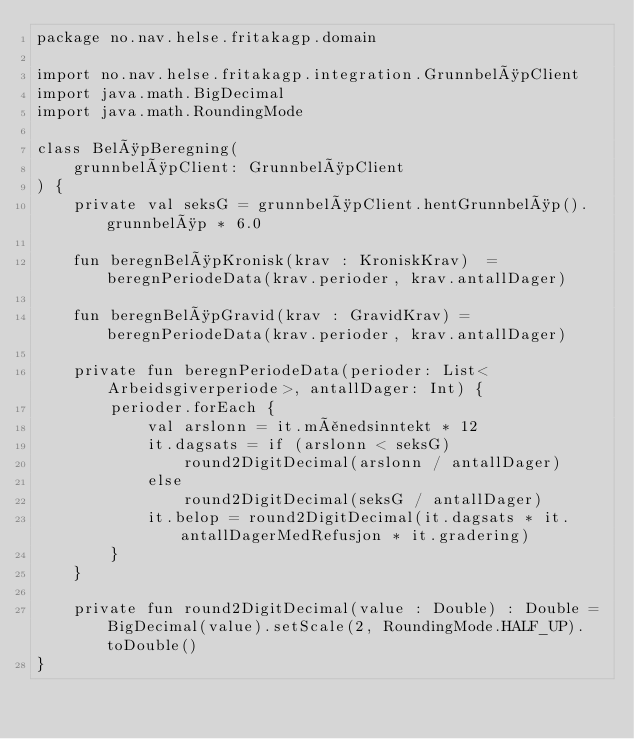Convert code to text. <code><loc_0><loc_0><loc_500><loc_500><_Kotlin_>package no.nav.helse.fritakagp.domain

import no.nav.helse.fritakagp.integration.GrunnbeløpClient
import java.math.BigDecimal
import java.math.RoundingMode

class BeløpBeregning(
    grunnbeløpClient: GrunnbeløpClient
) {
    private val seksG = grunnbeløpClient.hentGrunnbeløp().grunnbeløp * 6.0

    fun beregnBeløpKronisk(krav : KroniskKrav)  = beregnPeriodeData(krav.perioder, krav.antallDager)

    fun beregnBeløpGravid(krav : GravidKrav) = beregnPeriodeData(krav.perioder, krav.antallDager)

    private fun beregnPeriodeData(perioder: List<Arbeidsgiverperiode>, antallDager: Int) {
        perioder.forEach {
            val arslonn = it.månedsinntekt * 12
            it.dagsats = if (arslonn < seksG)
                round2DigitDecimal(arslonn / antallDager)
            else
                round2DigitDecimal(seksG / antallDager)
            it.belop = round2DigitDecimal(it.dagsats * it.antallDagerMedRefusjon * it.gradering)
        }
    }

    private fun round2DigitDecimal(value : Double) : Double = BigDecimal(value).setScale(2, RoundingMode.HALF_UP).toDouble()
}
</code> 